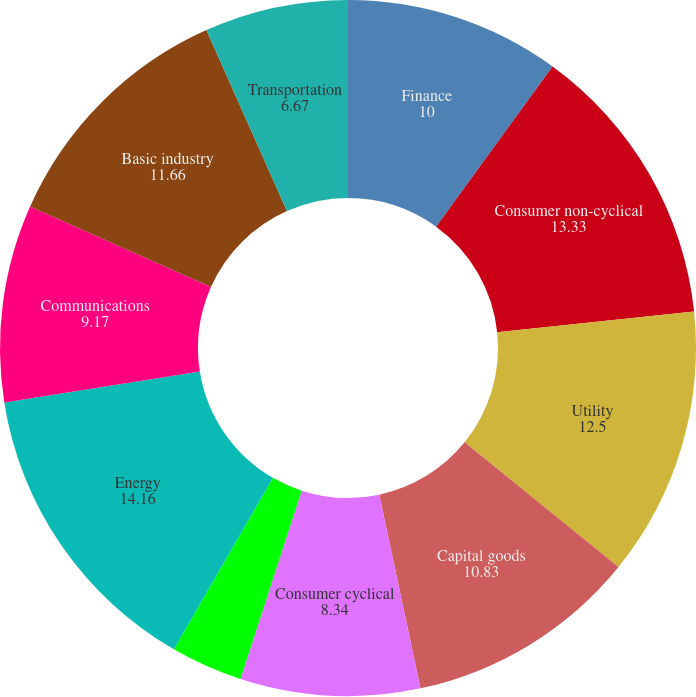Convert chart to OTSL. <chart><loc_0><loc_0><loc_500><loc_500><pie_chart><fcel>Finance<fcel>Consumer non-cyclical<fcel>Utility<fcel>Capital goods<fcel>Consumer cyclical<fcel>Foreign agencies<fcel>Energy<fcel>Communications<fcel>Basic industry<fcel>Transportation<nl><fcel>10.0%<fcel>13.33%<fcel>12.5%<fcel>10.83%<fcel>8.34%<fcel>3.34%<fcel>14.16%<fcel>9.17%<fcel>11.66%<fcel>6.67%<nl></chart> 